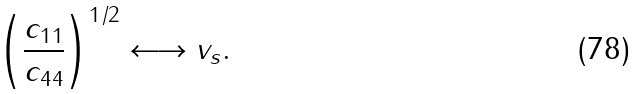<formula> <loc_0><loc_0><loc_500><loc_500>\left ( \frac { c _ { 1 1 } } { c _ { 4 4 } } \right ) ^ { 1 / 2 } \longleftrightarrow v _ { s } .</formula> 